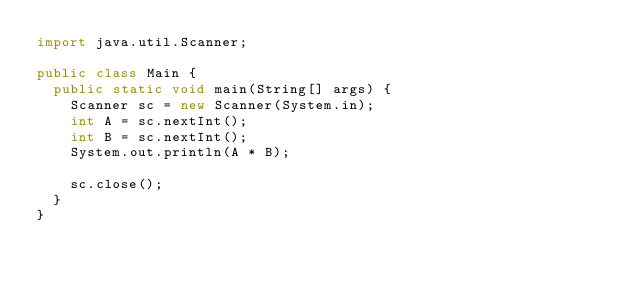Convert code to text. <code><loc_0><loc_0><loc_500><loc_500><_Java_>import java.util.Scanner;

public class Main {
	public static void main(String[] args) {
		Scanner sc = new Scanner(System.in);
		int A = sc.nextInt();
		int B = sc.nextInt();
		System.out.println(A * B);

		sc.close();
	}
}</code> 